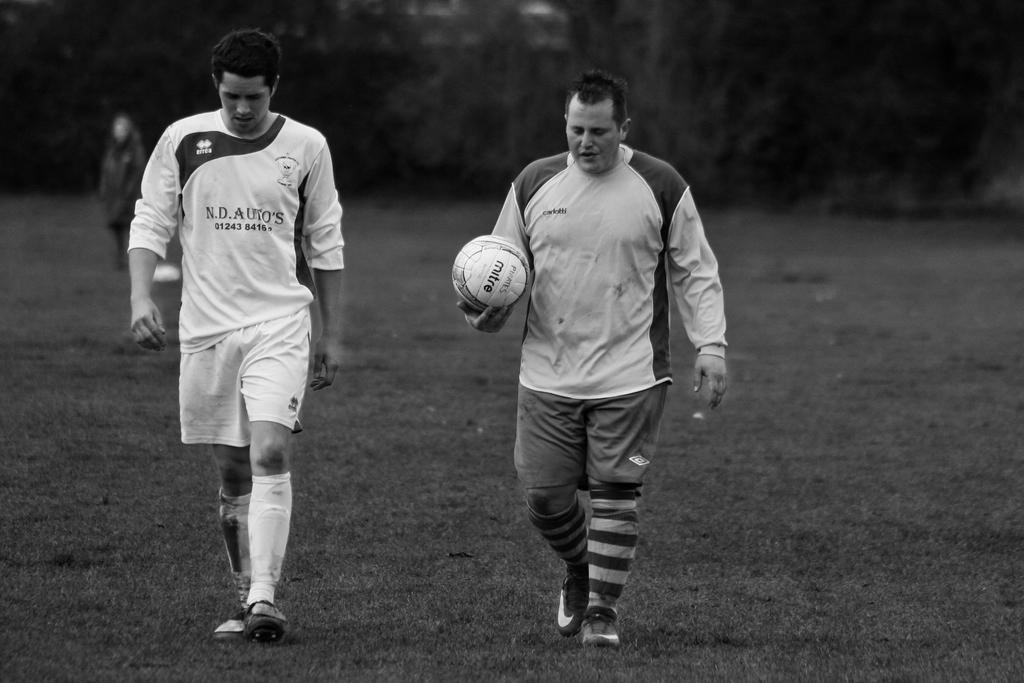Can you describe this image briefly? In the image there is man holding football and beside him there is another walking on a grass field. 